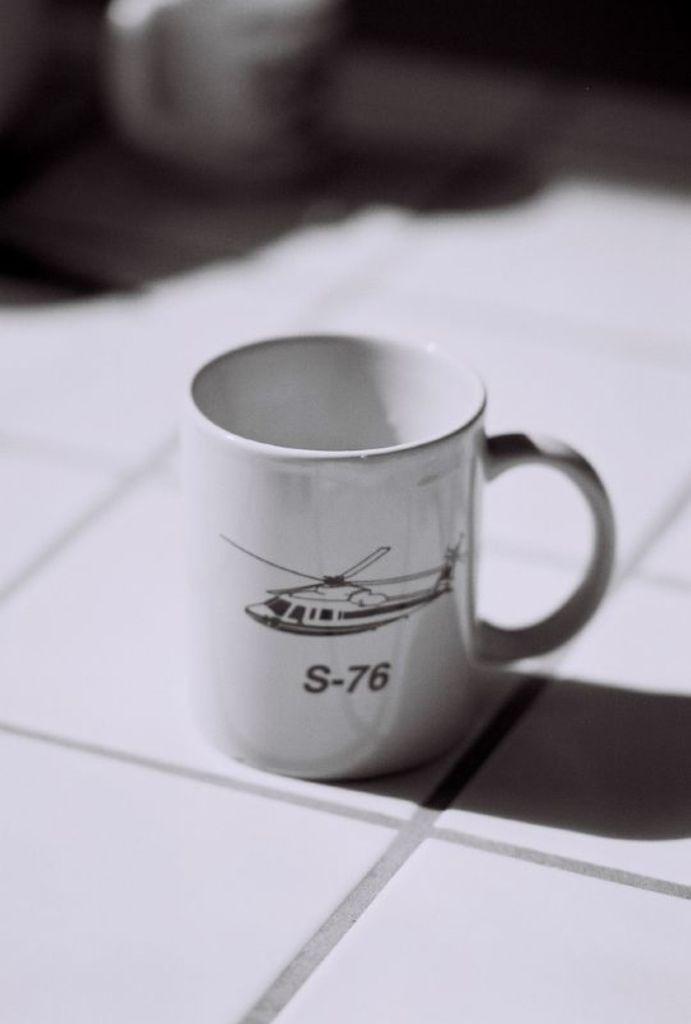What model of helicopter is depicted on the mug?
Offer a very short reply. S-76. 